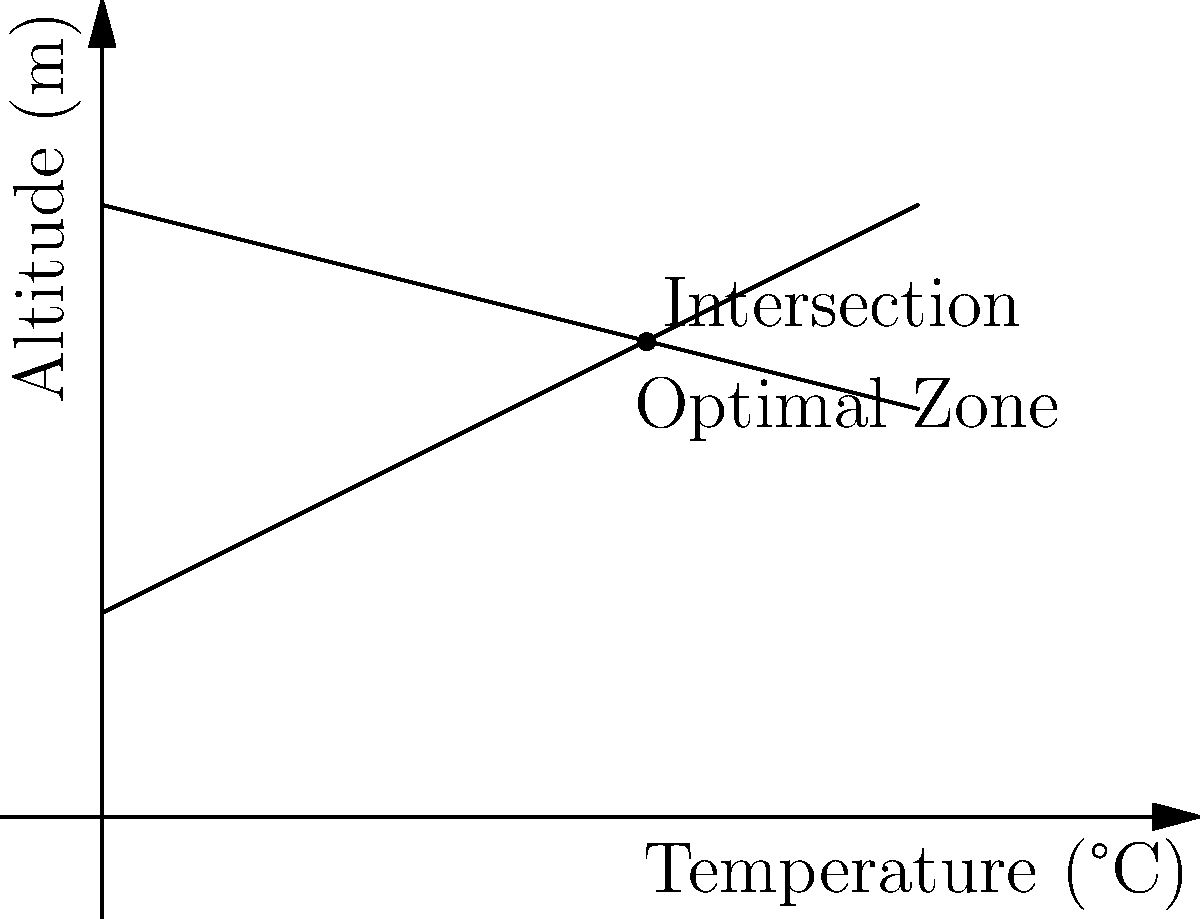In your caviar storage facility, the temperature gradient is represented by two intersecting lines as shown in the graph. The x-axis represents temperature in °C, and the y-axis represents altitude in meters. Line A is given by the equation $y = 0.5x + 1$, and Line B is given by $y = -0.25x + 3$. At what temperature do these lines intersect, indicating the optimal storage condition for your premium caviar? To find the intersection point of the two lines, we need to solve the system of equations:

1) $y = 0.5x + 1$ (Line A)
2) $y = -0.25x + 3$ (Line B)

At the intersection point, the y-values are equal, so:

3) $0.5x + 1 = -0.25x + 3$

Now, let's solve for x:

4) $0.5x + 0.25x = 3 - 1$
5) $0.75x = 2$
6) $x = 2 \div 0.75 = 2.67$ (rounded to 2 decimal places)

This x-value represents the temperature at the intersection point.

To verify, we can substitute this x-value into either of the original equations:

7) $y = 0.5(2.67) + 1 = 2.33$ (rounded to 2 decimal places)

Therefore, the intersection point is at (2.67°C, 2.33m).
Answer: 2.67°C 